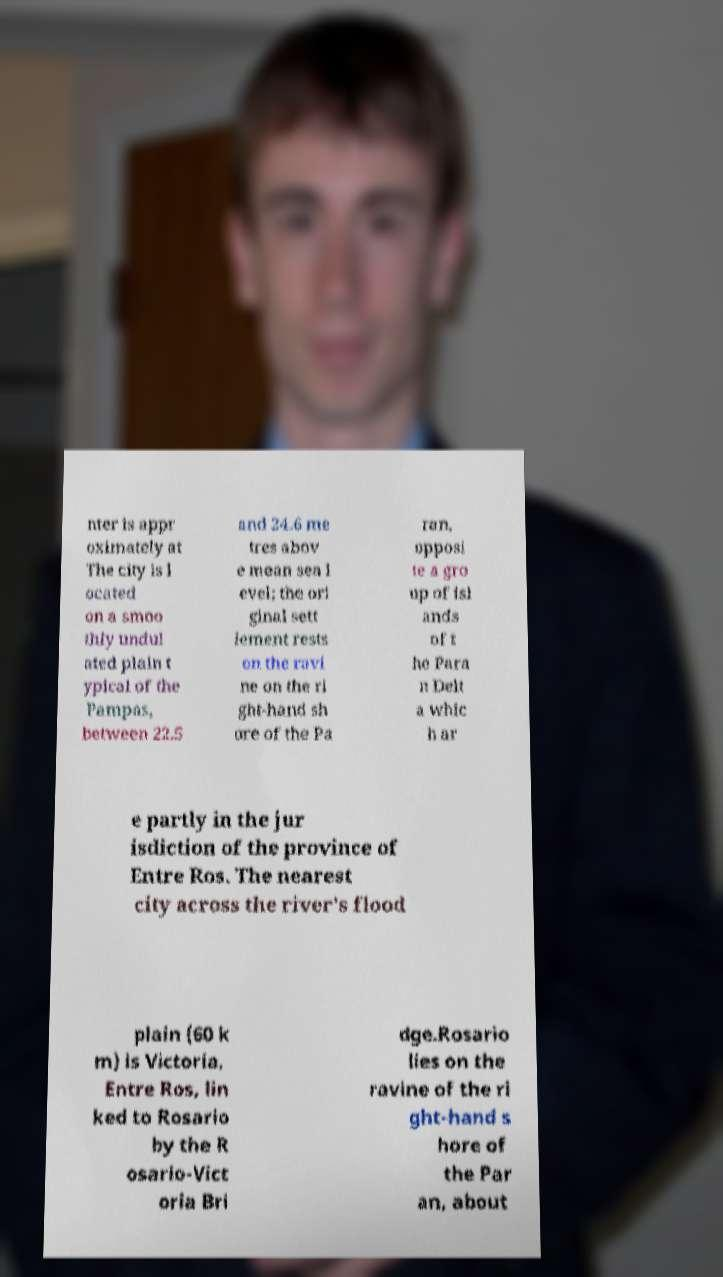There's text embedded in this image that I need extracted. Can you transcribe it verbatim? nter is appr oximately at The city is l ocated on a smoo thly undul ated plain t ypical of the Pampas, between 22.5 and 24.6 me tres abov e mean sea l evel; the ori ginal sett lement rests on the ravi ne on the ri ght-hand sh ore of the Pa ran, opposi te a gro up of isl ands of t he Para n Delt a whic h ar e partly in the jur isdiction of the province of Entre Ros. The nearest city across the river's flood plain (60 k m) is Victoria, Entre Ros, lin ked to Rosario by the R osario-Vict oria Bri dge.Rosario lies on the ravine of the ri ght-hand s hore of the Par an, about 